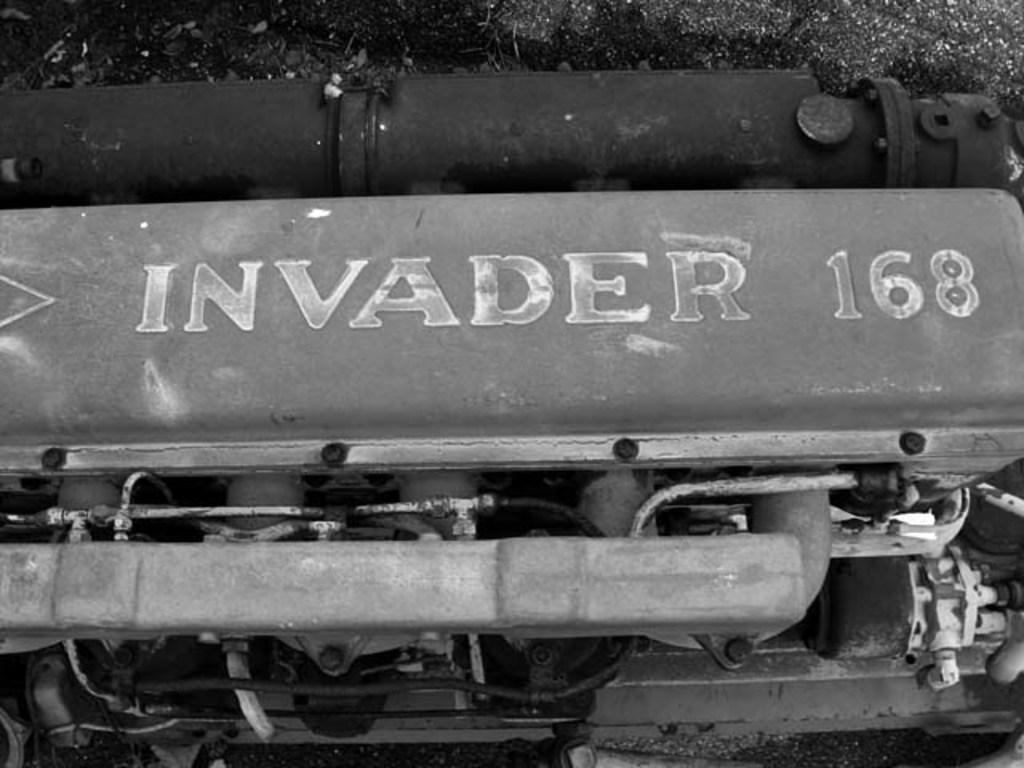<image>
Create a compact narrative representing the image presented. A railroad car has invader 168 in faded white paint. 